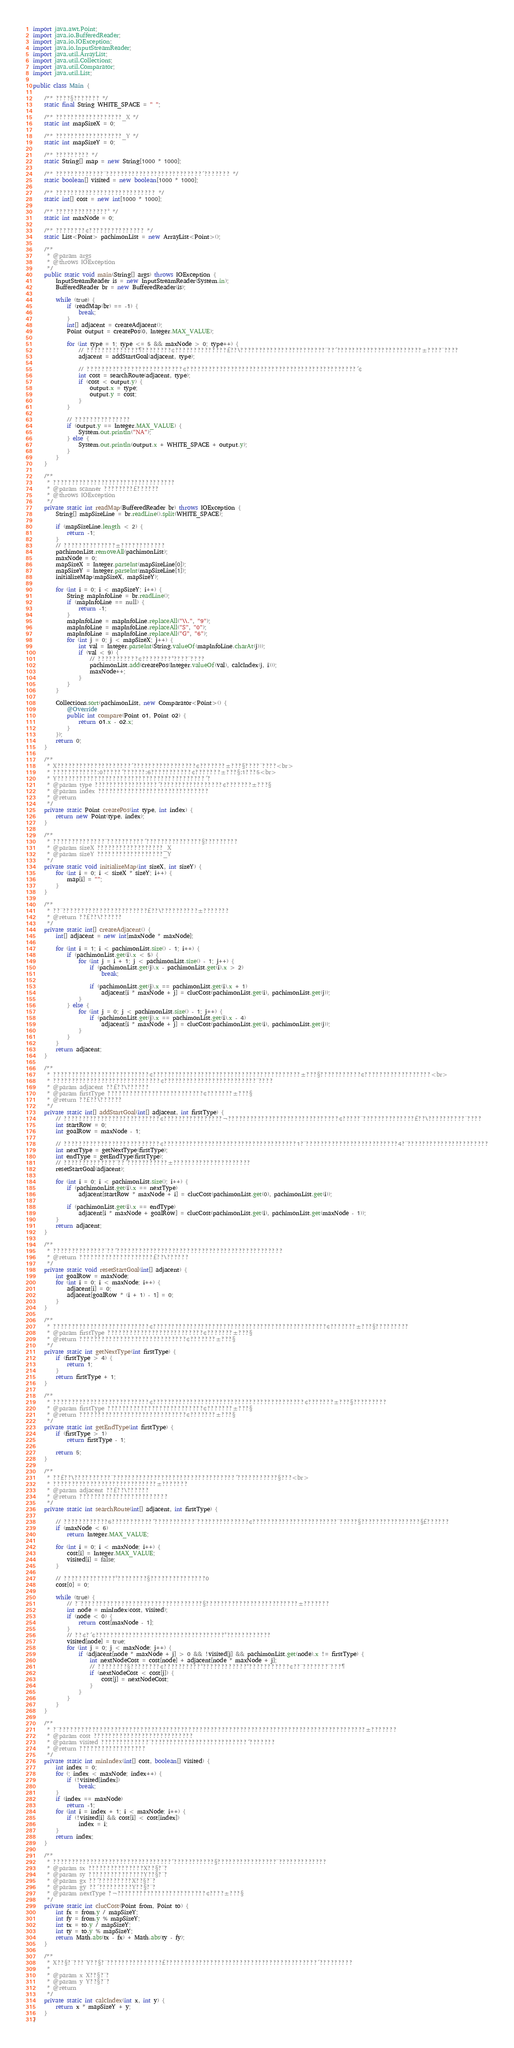<code> <loc_0><loc_0><loc_500><loc_500><_Java_>import java.awt.Point;
import java.io.BufferedReader;
import java.io.IOException;
import java.io.InputStreamReader;
import java.util.ArrayList;
import java.util.Collections;
import java.util.Comparator;
import java.util.List;

public class Main {

	/** ????§??????? */
	static final String WHITE_SPACE = " ";

	/** ??????????????????_X */
	static int mapSizeX = 0;

	/** ??????????????????_Y */
	static int mapSizeY = 0;

	/** ????????? */
	static String[] map = new String[1000 * 1000];

	/** ?????????????¨??????????????????????????´??????? */
	static boolean[] visited = new boolean[1000 * 1000];

	/** ??????????????????????????? */
	static int[] cost = new int[1000 * 1000];

	/** ??????????????° */
	static int maxNode = 0;

	/** ????????¢??????????????? */
	static List<Point> pachimonList = new ArrayList<Point>();

	/**
	 * @param args
	 * @throws IOException
	 */
	public static void main(String[] args) throws IOException {
		InputStreamReader is = new InputStreamReader(System.in);
		BufferedReader br = new BufferedReader(is);

		while (true) {
			if (readMap(br) == -1) {
				break;
			}
			int[] adjacent = createAdjacent();
			Point output = createPos(0, Integer.MAX_VALUE);

			for (int type = 1; type <= 5 && maxNode > 0; type++) {
				// ??????????????¶????????¢??????????????£??\???????????????????????¨??´???????????????????????±????¨????
				adjacent = addStartGoal(adjacent, type);

				// ??????????????????????????¢??????????????????????????????????????????????´¢
				int cost = searchRoute(adjacent, type);
				if (cost < output.y) {
					output.x = type;
					output.y = cost;
				}
			}

			// ???????????????
			if (output.y == Integer.MAX_VALUE) {
				System.out.println("NA");
			} else {
				System.out.println(output.x + WHITE_SPACE + output.y);
			}
		}
	}

	/**
	 * ?????????????????????????????????
	 * @param scanner ????????£??????
	 * @throws IOException
	 */
	private static int readMap(BufferedReader br) throws IOException {
		String[] mapSizeLine = br.readLine().split(WHITE_SPACE);

		if (mapSizeLine.length < 2) {
			return -1;
		}
		// ??????????????±????????????
		pachimonList.removeAll(pachimonList);
		maxNode = 0;
		mapSizeX = Integer.parseInt(mapSizeLine[0]);
		mapSizeY = Integer.parseInt(mapSizeLine[1]);
		initializeMap(mapSizeX, mapSizeY);

		for (int i = 0; i < mapSizeY; i++) {
			String mapInfoLine = br.readLine();
			if (mapInfoLine == null) {
				return -1;
			}
			mapInfoLine = mapInfoLine.replaceAll("\\.", "9");
			mapInfoLine = mapInfoLine.replaceAll("S", "0");
			mapInfoLine = mapInfoLine.replaceAll("G", "6");
			for (int j = 0; j < mapSizeX; j++) {
				int val = Integer.parseInt(String.valueOf(mapInfoLine.charAt(j)));
				if (val < 9) {
					// ???????????¢????????°????¨????
					pachimonList.add(createPos(Integer.valueOf(val), calcIndex(j, i)));
					maxNode++;
				}
			}
		}

		Collections.sort(pachimonList, new Comparator<Point>() {
			@Override
			public int compare(Point o1, Point o2) {
				return o1.x - o2.x;
			}
		});
		return 0;
	}

	/**
	 * X????????????????????´?????????????????¢???????±???§????¨????<br>
	 * ????????????:0?????´??????:6???????????¢???????±???§:1???5<br>
	 * Y????????????????????????????????????????´?
	 * @param type ?????????????????´?????????????????¢???????±???§
	 * @param index ??????????????????????????????
	 * @return
	 */
	private static Point createPos(int type, int index) {
		return new Point(type, index);
	}

	/**
	 * ??????????????¨??????????´???????????????§?????????
	 * @param sizeX ??????????????????_X
	 * @param sizeY ??????????????????_Y
	 */
	private static void initializeMap(int sizeX, int sizeY) {
		for (int i = 0; i < sizeX * sizeY; i++) {
			map[i] = "";
		}
	}

	/**
	 * ??¨???????????????????????£??\??????????±???????
	 * @return ??£??\??????
	 */
	private static int[] createAdjacent() {
		int[] adjacent = new int[maxNode * maxNode];

		for (int i = 1; i < pachimonList.size() - 1; i++) {
			if (pachimonList.get(i).x < 5) {
				for (int j = i + 1; j < pachimonList.size() - 1; j++) {
					if (pachimonList.get(j).x - pachimonList.get(i).x > 2)
						break;

					if (pachimonList.get(j).x == pachimonList.get(i).x + 1)
						adjacent[i * maxNode + j] = clucCost(pachimonList.get(i), pachimonList.get(j));
				}
			} else {
				for (int j = 0; j < pachimonList.size() - 1; j++) {
					if (pachimonList.get(j).x == pachimonList.get(i).x - 4)
						adjacent[i * maxNode + j] = clucCost(pachimonList.get(i), pachimonList.get(j));
				}
			}
		}
		return adjacent;
	}

	/**
	 * ??????????????????????????¢????????????????????????????????????????±???§???????????¢??????????????????<br>
	 * ?????????????????????????????¢?????????????????????????¨????
	 * @param adjacent ??£??\??????
	 * @param firstType ??????????????????????????¢???????±???§
	 * @return ??£??\??????
	 */
	private static int[] addStartGoal(int[] adjacent, int firstType) {
		// ??????????????????????????¢????????????????¬??????????????????????????????¢?????¨??????????????£??\??????????¨????
		int startRow = 0;
		int goalRow = maxNode - 1;

		// ??????????????????????????¢????????????????????????????????????1?¨?????????????????????????4?¨??????????????????????
		int nextType = getNextType(firstType);
		int endType = getEndType(firstType);
		// ??????????????¨??´???????????±?????????????????????
		resetStartGoal(adjacent);

		for (int i = 0; i < pachimonList.size(); i++) {
			if (pachimonList.get(i).x == nextType)
				adjacent[startRow * maxNode + i] = clucCost(pachimonList.get(0), pachimonList.get(i));

			if (pachimonList.get(i).x == endType)
				adjacent[i * maxNode + goalRow] = clucCost(pachimonList.get(i), pachimonList.get(maxNode - 1));
		}
		return adjacent;
	}

	/**
	 * ??????????????¨??´?????????????????????????????????????????????
	 * @return ????????????????????£??\??????
	 */
	private static void resetStartGoal(int[] adjacent) {
		int goalRow = maxNode;
		for (int i = 0; i < maxNode; i++) {
			adjacent[i] = 0;
			adjacent[goalRow * (i + 1) - 1] = 0;
		}
	}

	/**
	 * ??????????????????????????¢???????????????????????????????????????????????¢???????±???§?????????
	 * @param firstType ??????????????????????????¢???????±???§
	 * @return ?????????????????????????????¢???????±???§
	 */
	private static int getNextType(int firstType) {
		if (firstType > 4) {
			return 1;
		}
		return firstType + 1;
	}

	/**
	 * ??????????????????????????¢?????????????????????????????????????????¢???????±???§?????????
	 * @param firstType ??????????????????????????¢???????±???§
	 * @return ?????????????????????????????¢???????±???§
	 */
	private static int getEndType(int firstType) {
		if (firstType > 1)
			return firstType - 1;

		return 5;
	}

	/**
	 * ??£??\??????????¨?????????????????????????????????´???????????§???<br>
	 * ????????????????????????????±???????
	 * @param adjacent ??£??\??????
	 * @return ????????????????????????
	 */
	private static int searchRoute(int[] adjacent, int firstType) {

		// ????????????6???????????´???????????¨??????????????¢???????????????????????¨?????§????????????????§£??????
		if (maxNode < 6)
			return Integer.MAX_VALUE;

		for (int i = 0; i < maxNode; i++) {
			cost[i] = Integer.MAX_VALUE;
			visited[i] = false;
		}

		// ??????????????°????????§???????????????0
		cost[0] = 0;

		while (true) {
			// ?¨?????????????????????????????????§?????????????????????????±???????
			int node = minIndex(cost, visited);
			if (node < 0) {
				return cost[maxNode - 1];
			}
			// ??¢?´¢???????????????????????????????????°????????????
			visited[node] = true;
			for (int j = 0; j < maxNode; j++) {
				if (adjacent[node * maxNode + j] > 0 && !visited[j] && pachimonList.get(node).x != firstType) {
					int nextNodeCost = cost[node] + adjacent[node * maxNode + j];
					// ????????§????????¢??????????°????????????°???????????¢??¨???????¨???¶
					if (nextNodeCost < cost[j]) {
						cost[j] = nextNodeCost;
					}
				}
			}
		}
	}

	/**
	 * ?¨???????????????????????????????????????????????????????????????????????????????????±???????
	 * @param cost ???????????????????????????
	 * @param visited ?????????????¨??????????????????????????´???????
	 * @return ??????????????????
	 */
	private static int minIndex(int[] cost, boolean[] visited) {
		int index = 0;
		for (; index < maxNode; index++) {
			if (!visited[index])
				break;
		}
		if (index == maxNode)
			return -1;
		for (int i = index + 1; i < maxNode; i++) {
			if (!visited[i] && cost[i] < cost[index])
				index = i;
		}
		return index;
	}

	/**
	 * ????????????????????????????????´???????????§????????????????¨?????????????
	 * @param sx ???????????????X??§?¨?
	 * @param sy ???????????????Y??§?¨?
	 * @param gx ??´?????????X??§?¨?
	 * @param gy ??´?????????Y??§?¨?
	 * @param nextType ?¬????????????????????????¢????±???§
	 */
	private static int clucCost(Point from, Point to) {
		int fx = from.y / mapSizeY;
		int fy = from.y % mapSizeY;
		int tx = to.y / mapSizeY;
		int ty = to.y % mapSizeY;
		return Math.abs(tx - fx) + Math.abs(ty - fy);
	}

	/**
	 * X??§?¨???¨Y??§?¨???????????????£?????????????????????????????????????????´?????????
	 *
	 * @param x X??§?¨?
	 * @param y Y??§?¨?
	 * @return
	 */
	private static int calcIndex(int x, int y) {
		return x * mapSizeY + y;
	}
}</code> 